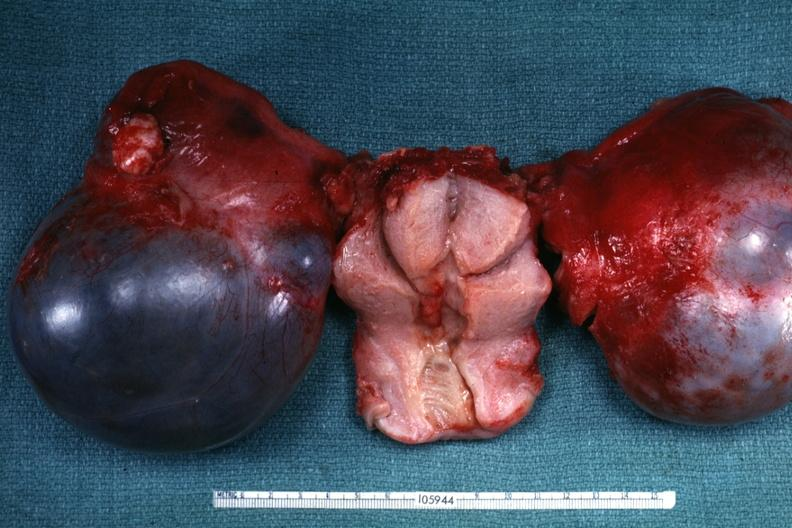what is not obvious from gross appearance?
Answer the question using a single word or phrase. External view of bilateral cystic ovarian tumors with uterus slide labeled cystadenocarcinoma malignancy 